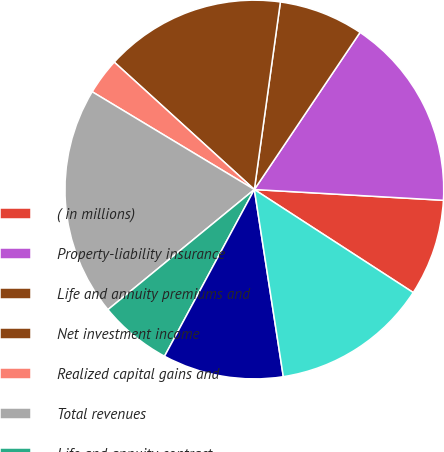Convert chart. <chart><loc_0><loc_0><loc_500><loc_500><pie_chart><fcel>( in millions)<fcel>Property-liability insurance<fcel>Life and annuity premiums and<fcel>Net investment income<fcel>Realized capital gains and<fcel>Total revenues<fcel>Life and annuity contract<fcel>Interest credited to<fcel>Amortization of deferred<nl><fcel>8.25%<fcel>16.48%<fcel>7.23%<fcel>15.45%<fcel>3.11%<fcel>19.57%<fcel>6.2%<fcel>10.31%<fcel>13.4%<nl></chart> 